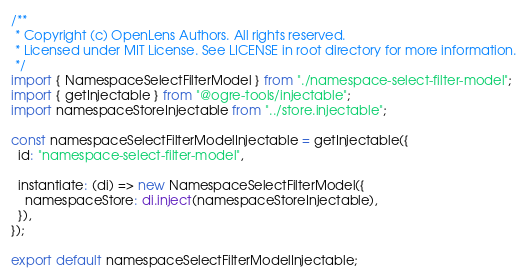Convert code to text. <code><loc_0><loc_0><loc_500><loc_500><_TypeScript_>/**
 * Copyright (c) OpenLens Authors. All rights reserved.
 * Licensed under MIT License. See LICENSE in root directory for more information.
 */
import { NamespaceSelectFilterModel } from "./namespace-select-filter-model";
import { getInjectable } from "@ogre-tools/injectable";
import namespaceStoreInjectable from "../store.injectable";

const namespaceSelectFilterModelInjectable = getInjectable({
  id: "namespace-select-filter-model",

  instantiate: (di) => new NamespaceSelectFilterModel({
    namespaceStore: di.inject(namespaceStoreInjectable),
  }),
});

export default namespaceSelectFilterModelInjectable;
</code> 